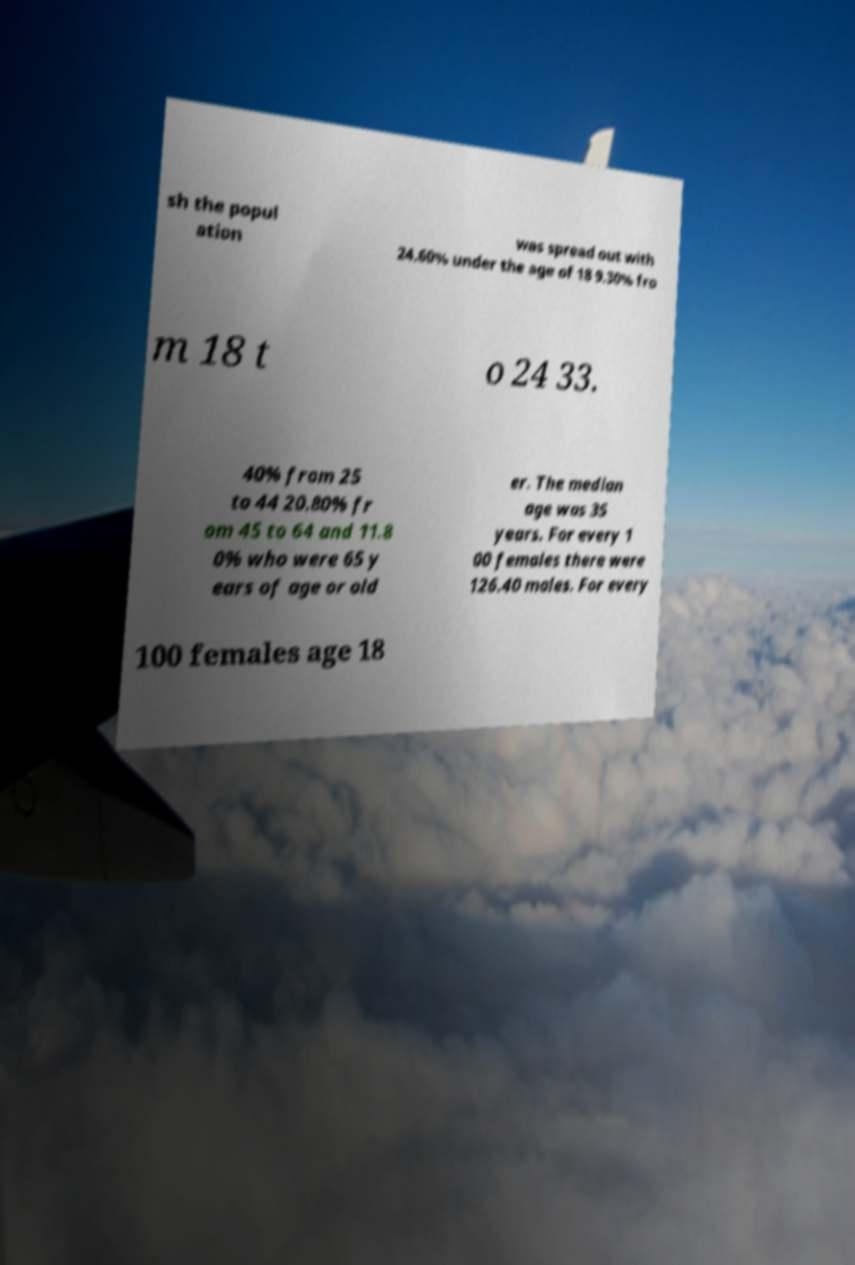Can you read and provide the text displayed in the image?This photo seems to have some interesting text. Can you extract and type it out for me? sh the popul ation was spread out with 24.60% under the age of 18 9.30% fro m 18 t o 24 33. 40% from 25 to 44 20.80% fr om 45 to 64 and 11.8 0% who were 65 y ears of age or old er. The median age was 35 years. For every 1 00 females there were 126.40 males. For every 100 females age 18 